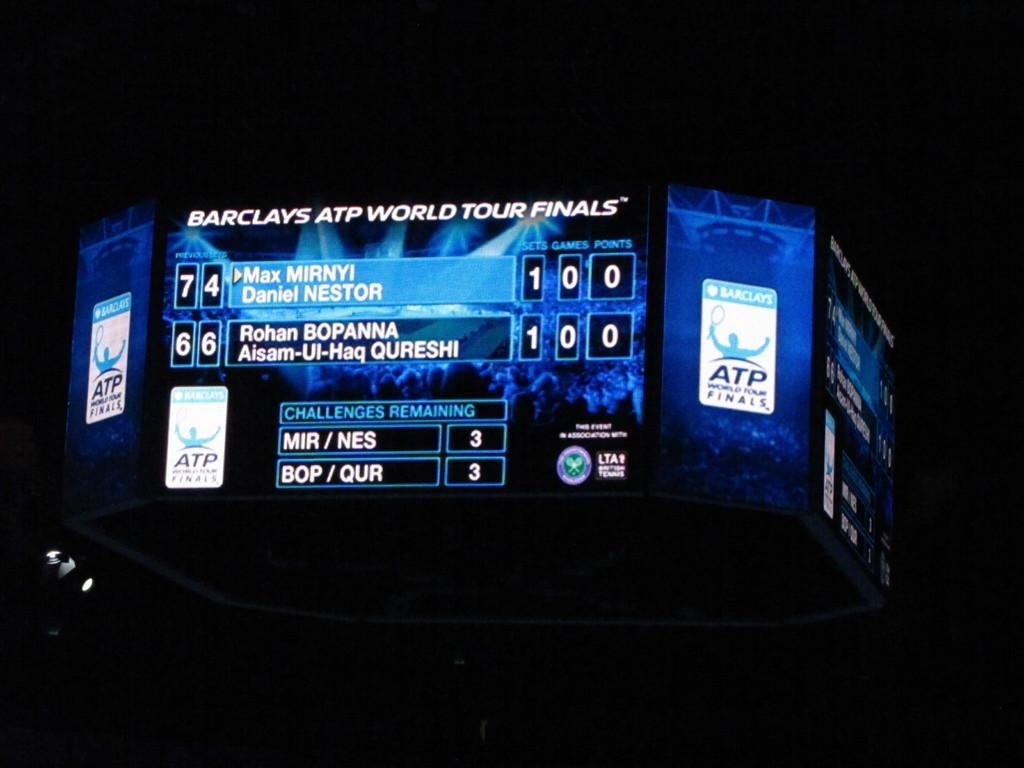Provide a one-sentence caption for the provided image. A large montir displaying the score of a game taking place at the Barclays ATP World Tour Finals. 